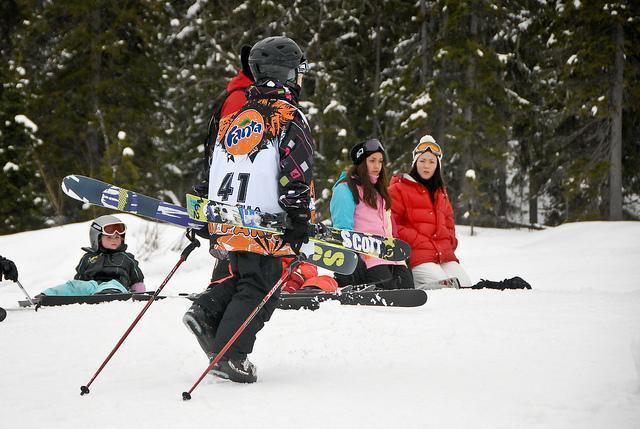How many people are there?
Give a very brief answer. 4. 